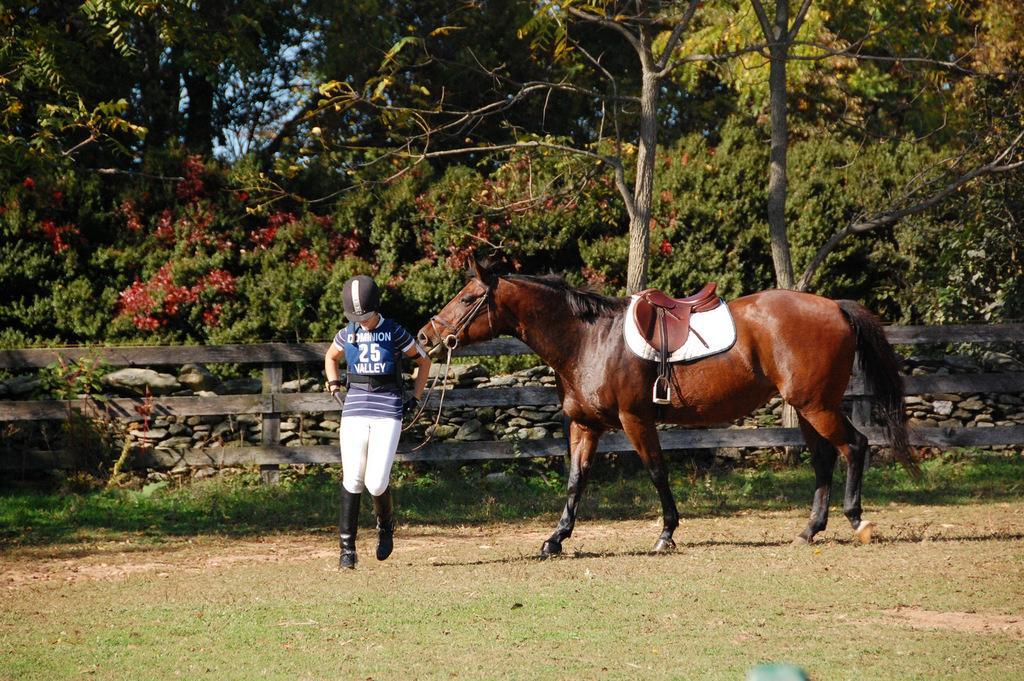Describe this image in one or two sentences. In this picture we can see a horse, person on the ground and in the background we can see a fence, stones, trees, sky. 